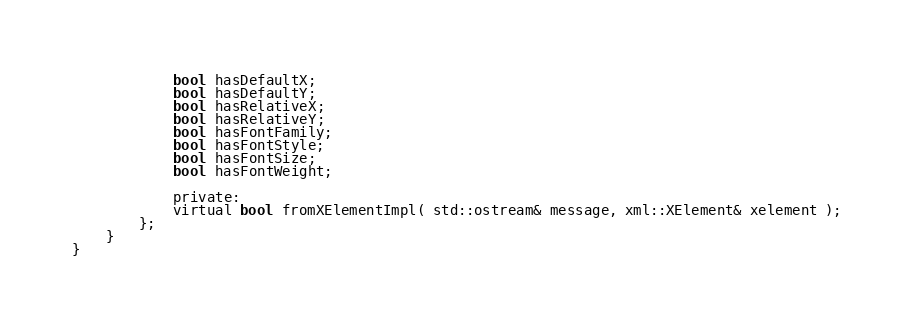Convert code to text. <code><loc_0><loc_0><loc_500><loc_500><_C_>            bool hasDefaultX;
            bool hasDefaultY;
            bool hasRelativeX;
            bool hasRelativeY;
            bool hasFontFamily;
            bool hasFontStyle;
            bool hasFontSize;
            bool hasFontWeight;

            private:
            virtual bool fromXElementImpl( std::ostream& message, xml::XElement& xelement );
        };
    }
}
</code> 